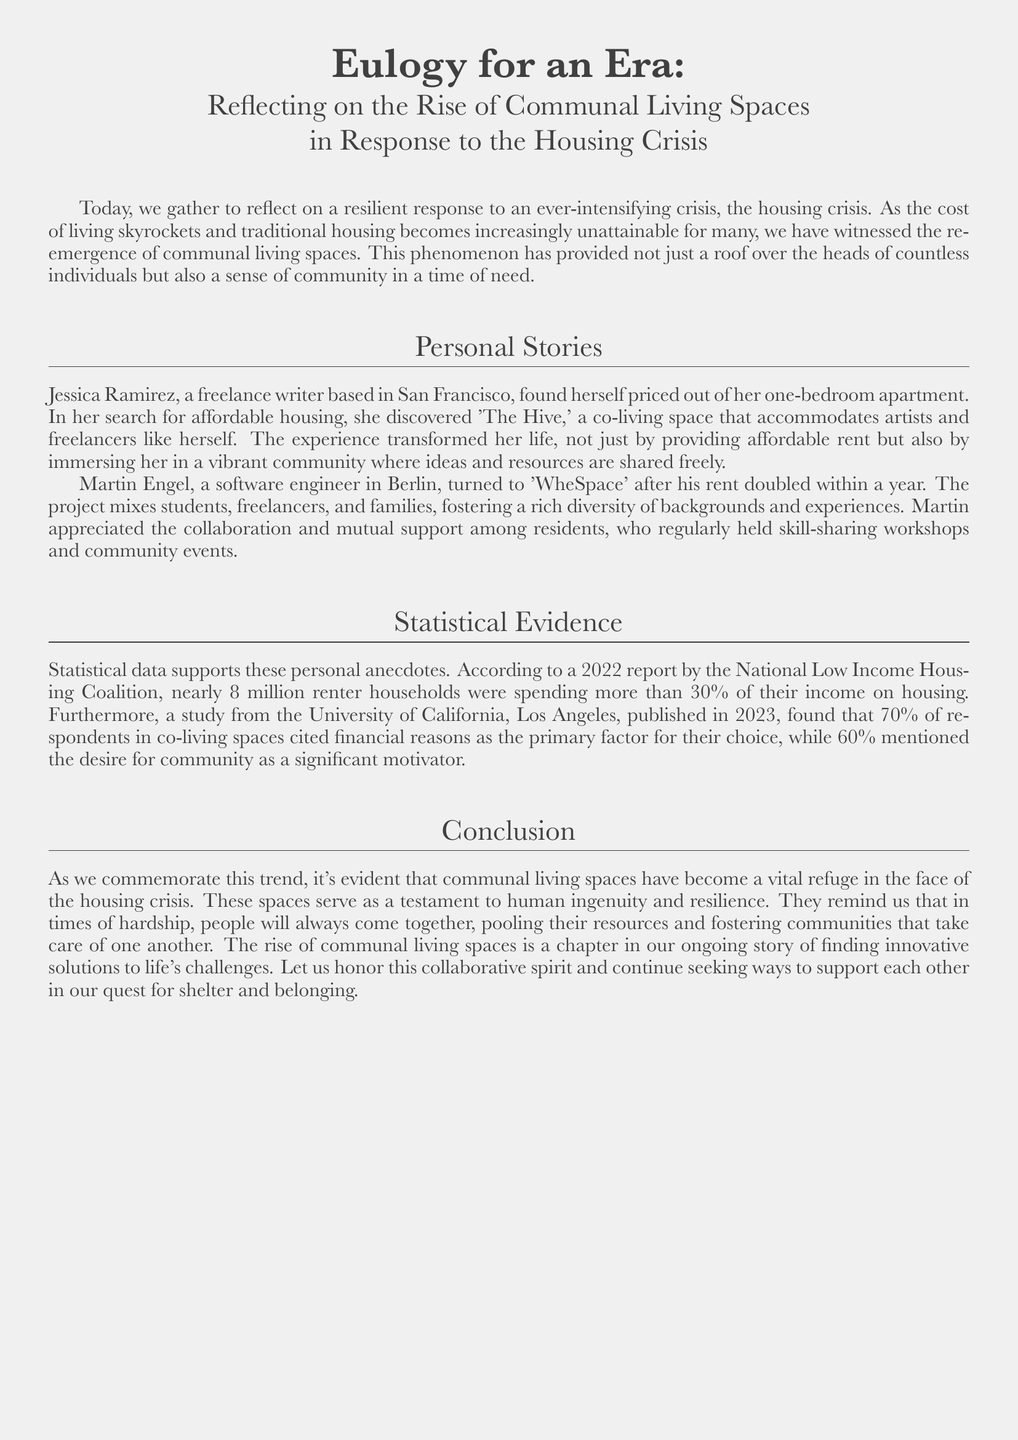What is the title of the document? The title is mentioned at the top of the document, which reflects on communal living spaces.
Answer: Eulogy for an Era: Reflecting on the Rise of Communal Living Spaces in Response to the Housing Crisis Who is the first person mentioned in the personal stories? The first personal story introduces a freelance writer based in San Francisco.
Answer: Jessica Ramirez What is the name of the co-living space Jessica Ramirez discovered? The document provides the name of the co-living space Jessica found during her housing search.
Answer: The Hive What percentage of renter households spent more than 30% of their income on housing? According to the statistical evidence in the document, this percentage reflects the housing crisis's severity.
Answer: nearly 8 million What was the primary reason for 70% of respondents choosing co-living spaces? The document states this percentage reflects the financial aspect influencing people's decisions.
Answer: financial reasons What type of events do residents of WheSpace hold for community engagement? The personal story of Martin Engel highlights this aspect of his living experience.
Answer: skill-sharing workshops What is the year the UCLA study was published? The document specifically mentions the publication date of the study related to co-living.
Answer: 2023 What does the document suggest about human ingenuity in relation to communal living? This statement reflects the overarching message of resilience and resourcefulness in the housing crisis.
Answer: vital refuge 